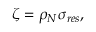Convert formula to latex. <formula><loc_0><loc_0><loc_500><loc_500>\zeta = \rho _ { N } \sigma _ { r e s } ,</formula> 